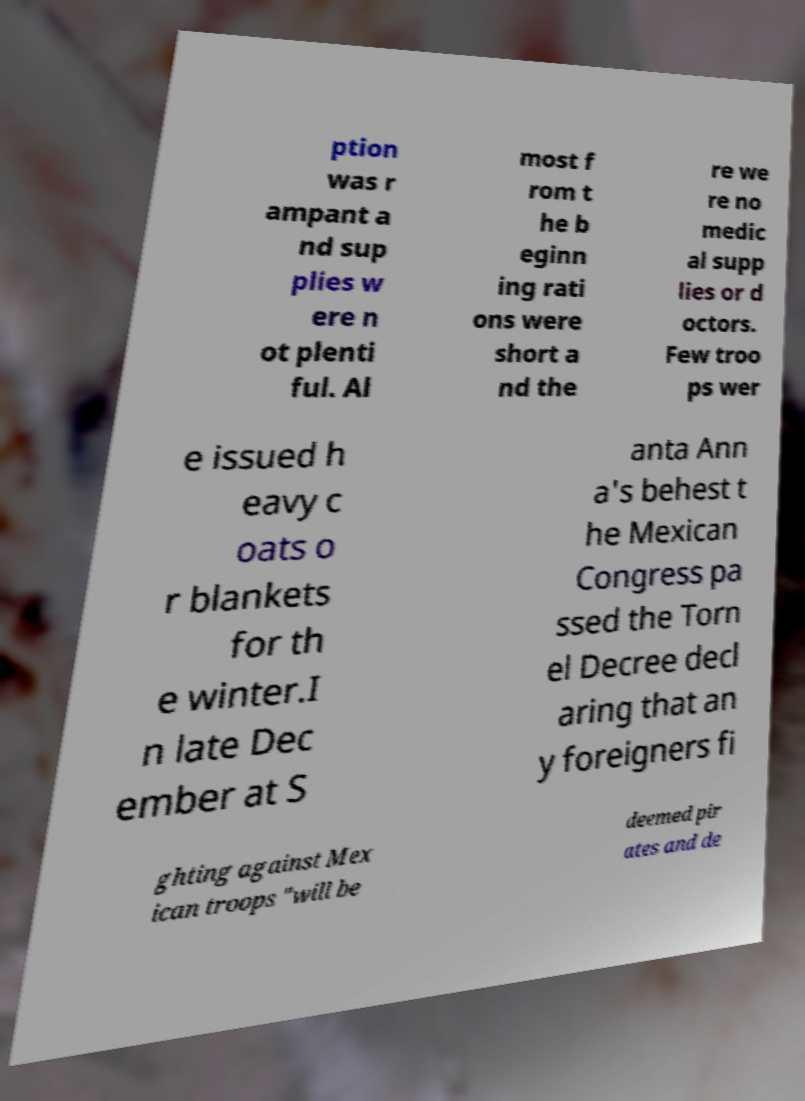Could you assist in decoding the text presented in this image and type it out clearly? ption was r ampant a nd sup plies w ere n ot plenti ful. Al most f rom t he b eginn ing rati ons were short a nd the re we re no medic al supp lies or d octors. Few troo ps wer e issued h eavy c oats o r blankets for th e winter.I n late Dec ember at S anta Ann a's behest t he Mexican Congress pa ssed the Torn el Decree decl aring that an y foreigners fi ghting against Mex ican troops "will be deemed pir ates and de 